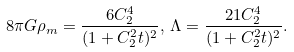<formula> <loc_0><loc_0><loc_500><loc_500>8 \pi G \rho _ { m } = \frac { 6 C _ { 2 } ^ { 4 } } { ( 1 + C _ { 2 } ^ { 2 } t ) ^ { 2 } } , \, \Lambda = \frac { 2 1 C _ { 2 } ^ { 4 } } { ( 1 + C _ { 2 } ^ { 2 } t ) ^ { 2 } } .</formula> 